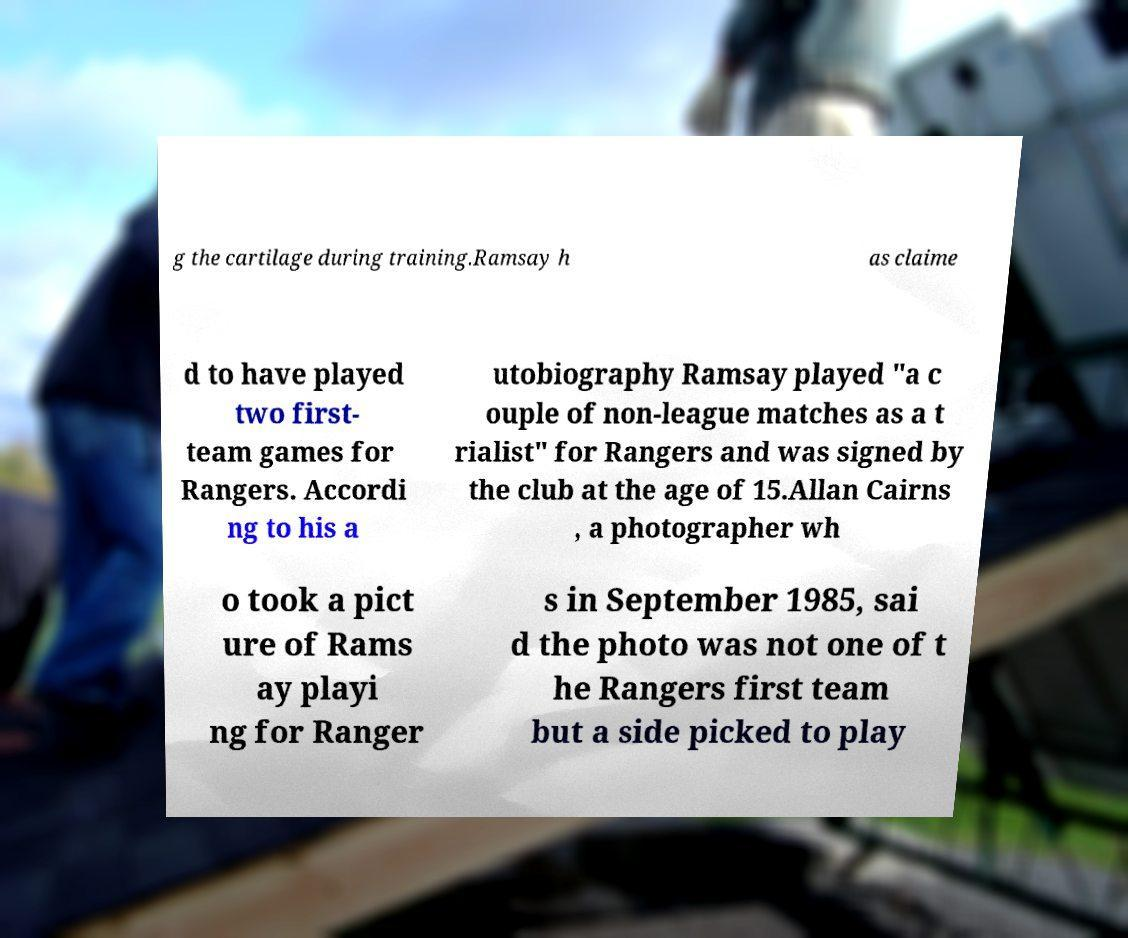Could you assist in decoding the text presented in this image and type it out clearly? g the cartilage during training.Ramsay h as claime d to have played two first- team games for Rangers. Accordi ng to his a utobiography Ramsay played "a c ouple of non-league matches as a t rialist" for Rangers and was signed by the club at the age of 15.Allan Cairns , a photographer wh o took a pict ure of Rams ay playi ng for Ranger s in September 1985, sai d the photo was not one of t he Rangers first team but a side picked to play 